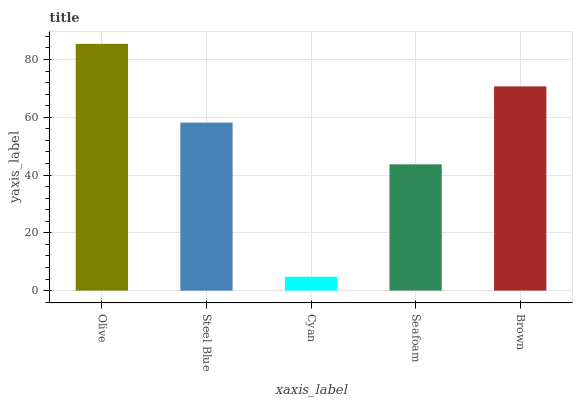Is Cyan the minimum?
Answer yes or no. Yes. Is Olive the maximum?
Answer yes or no. Yes. Is Steel Blue the minimum?
Answer yes or no. No. Is Steel Blue the maximum?
Answer yes or no. No. Is Olive greater than Steel Blue?
Answer yes or no. Yes. Is Steel Blue less than Olive?
Answer yes or no. Yes. Is Steel Blue greater than Olive?
Answer yes or no. No. Is Olive less than Steel Blue?
Answer yes or no. No. Is Steel Blue the high median?
Answer yes or no. Yes. Is Steel Blue the low median?
Answer yes or no. Yes. Is Cyan the high median?
Answer yes or no. No. Is Seafoam the low median?
Answer yes or no. No. 